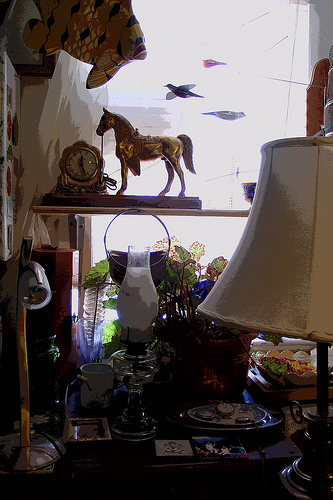<image>
Is there a clock in front of the horse? Yes. The clock is positioned in front of the horse, appearing closer to the camera viewpoint. 